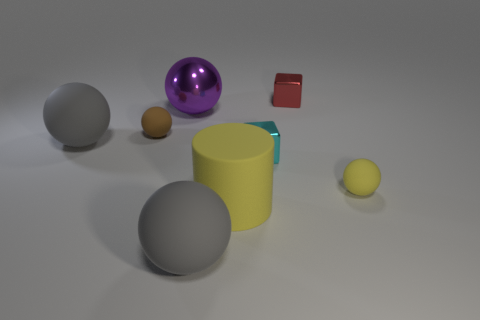There is a gray thing on the left side of the large ball in front of the tiny cyan object; what is its material?
Your answer should be compact. Rubber. What number of other metallic things have the same shape as the tiny brown thing?
Provide a short and direct response. 1. There is a gray rubber object on the right side of the matte ball behind the gray rubber object that is behind the tiny cyan cube; what size is it?
Give a very brief answer. Large. What number of green things are cubes or large matte objects?
Give a very brief answer. 0. Does the large gray thing that is to the right of the metal ball have the same shape as the small brown rubber thing?
Your answer should be compact. Yes. Are there more yellow things behind the large yellow cylinder than yellow rubber objects?
Offer a very short reply. No. How many red blocks have the same size as the cyan shiny block?
Make the answer very short. 1. What is the size of the sphere that is the same color as the matte cylinder?
Provide a succinct answer. Small. What number of objects are tiny yellow spheres or big gray rubber spheres that are behind the small yellow thing?
Make the answer very short. 2. What color is the object that is both in front of the small cyan cube and to the right of the big cylinder?
Provide a short and direct response. Yellow. 